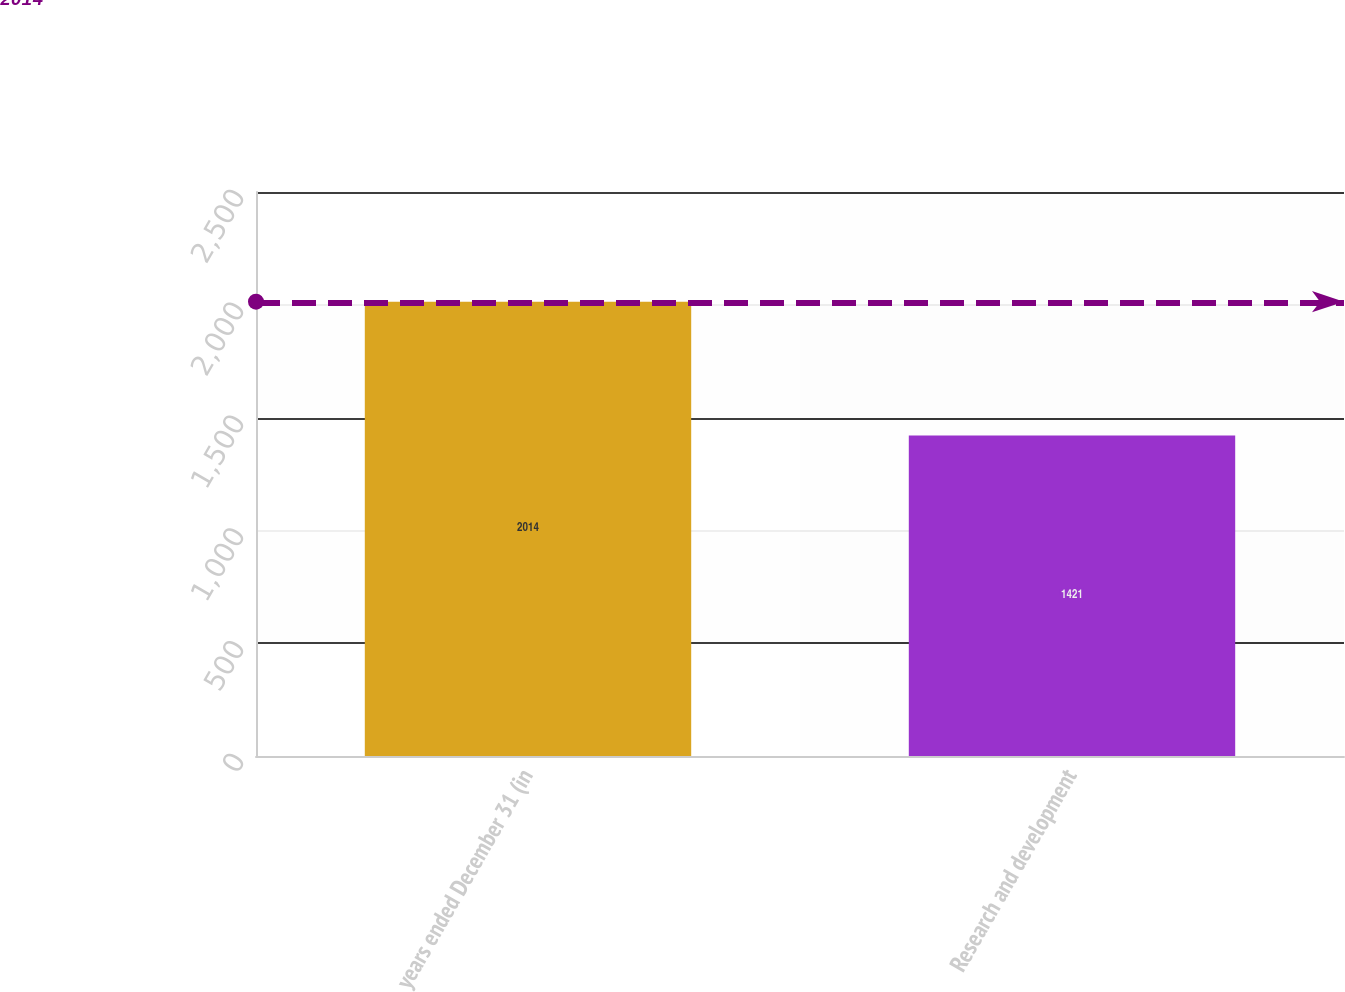Convert chart to OTSL. <chart><loc_0><loc_0><loc_500><loc_500><bar_chart><fcel>years ended December 31 (in<fcel>Research and development<nl><fcel>2014<fcel>1421<nl></chart> 